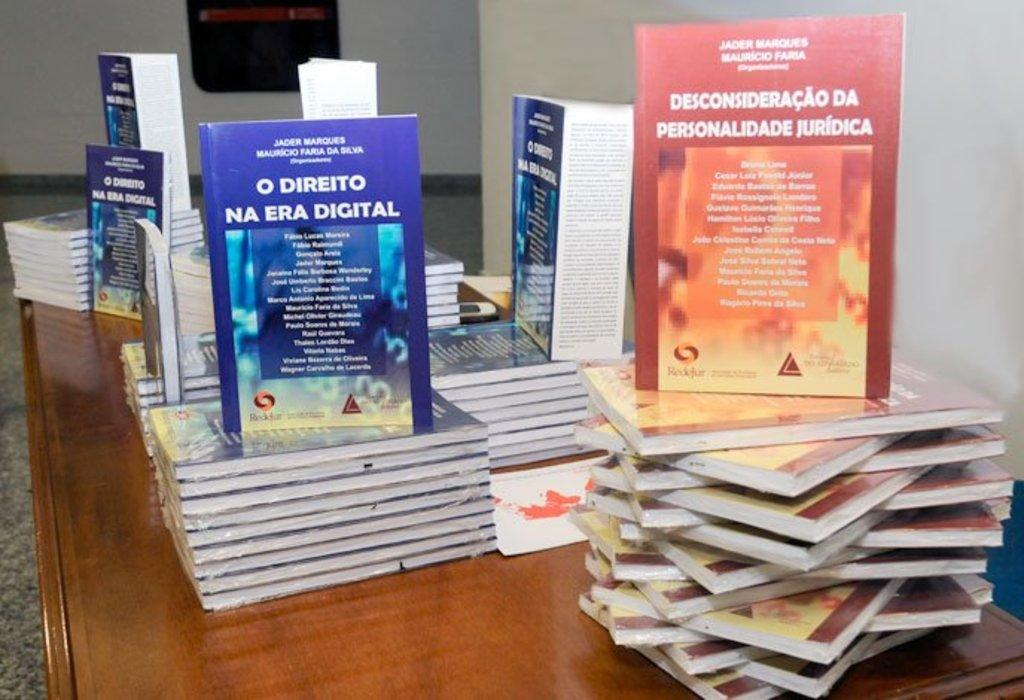<image>
Summarize the visual content of the image. A display of books includes O Direito Na Era Digital and Desconsideraca Da Personalidade Juridica. 